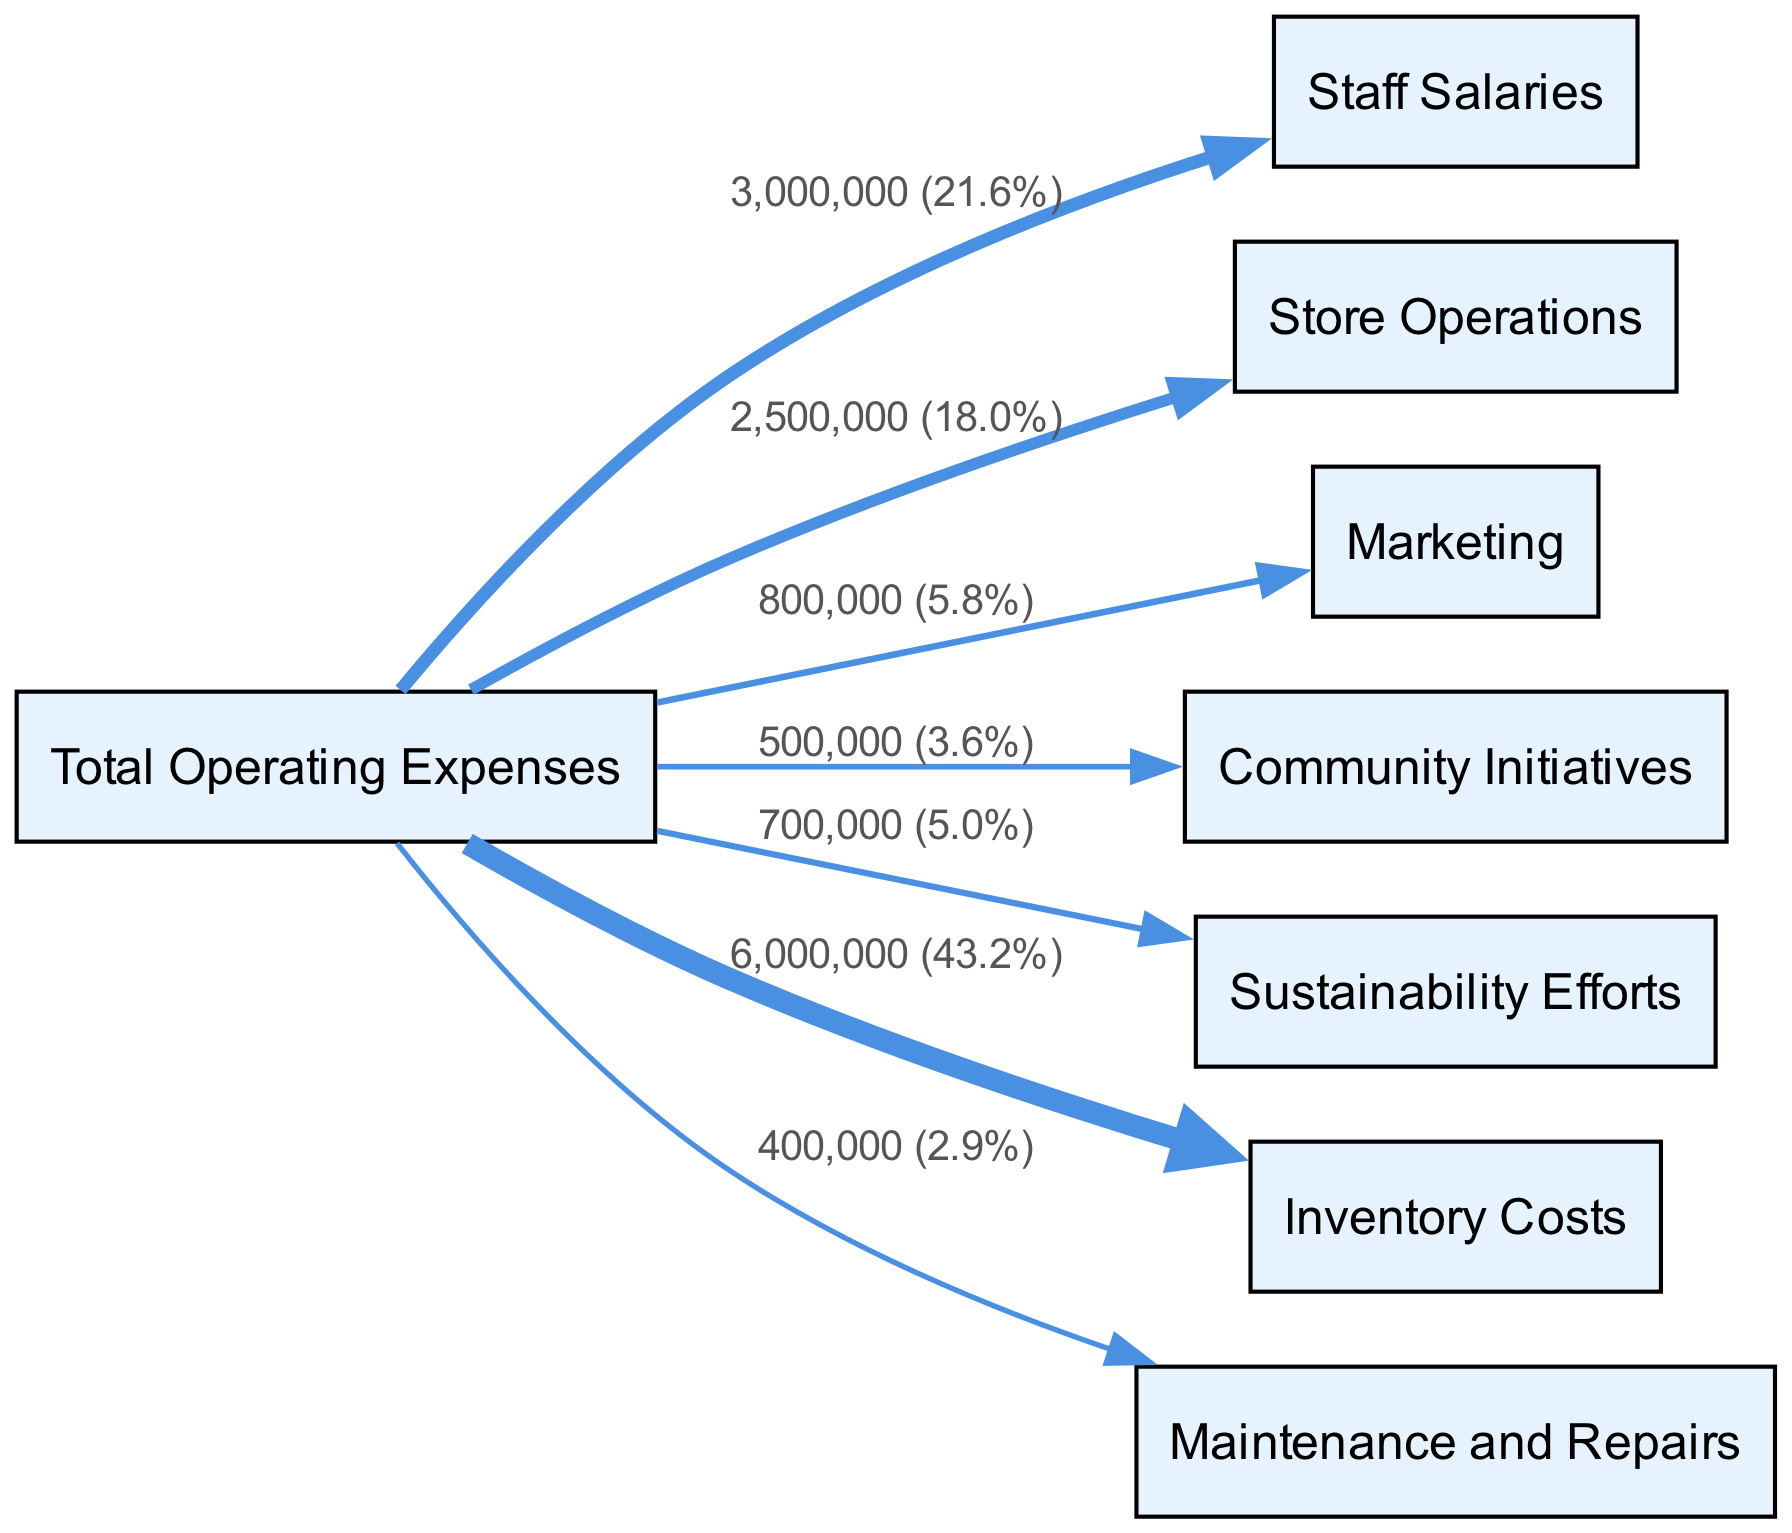What are the total operating expenses? The total operating expenses are shown as the starting node in the Sankey Diagram. By looking at the labeled link connected to the "Total Operating Expenses" node, we see the value is 12,000,000.
Answer: 12,000,000 What percentage of total operating expenses is allocated to community initiatives? The link for "Community Initiatives" shows a value of 500,000. To find the percentage, we use the formula (500,000 / 12,000,000) * 100, which results in approximately 4.2%.
Answer: 4.2% How much is spent on staff salaries? The diagram indicates a direct link from "Total Operating Expenses" to "Staff Salaries". The associated value displayed is 3,000,000.
Answer: 3,000,000 What is the total allocated to sustainability efforts? The "Sustainability Efforts" node indicates a value directly linked from "Total Operating Expenses". The amount shown is 700,000.
Answer: 700,000 Which node has the largest allocation and what is the amount? By examining the values displayed for each link from "Total Operating Expenses", "Inventory Costs" shows the highest value at 6,000,000.
Answer: Inventory Costs, 6,000,000 What is the combined total of community initiatives and sustainability efforts? To find this, we sum the values of the "Community Initiatives" (500,000) and "Sustainability Efforts" (700,000), which totals 1,200,000.
Answer: 1,200,000 How many nodes are displayed in the diagram? The nodes listed in the diagram are counted: there are a total of 8 nodes present.
Answer: 8 What fraction of the total operating expenses is used for marketing compared to staff salaries? The link for "Marketing" shows 800,000, while for "Staff Salaries", it shows 3,000,000. The fraction is thus 800,000 / 3,000,000, which simplifies to 0.267 (or roughly 27%).
Answer: 0.267 (27%) What budget category has the lowest expense and what is the value? A review of the links shows "Maintenance and Repairs" has the lowest value at 400,000.
Answer: Maintenance and Repairs, 400,000 